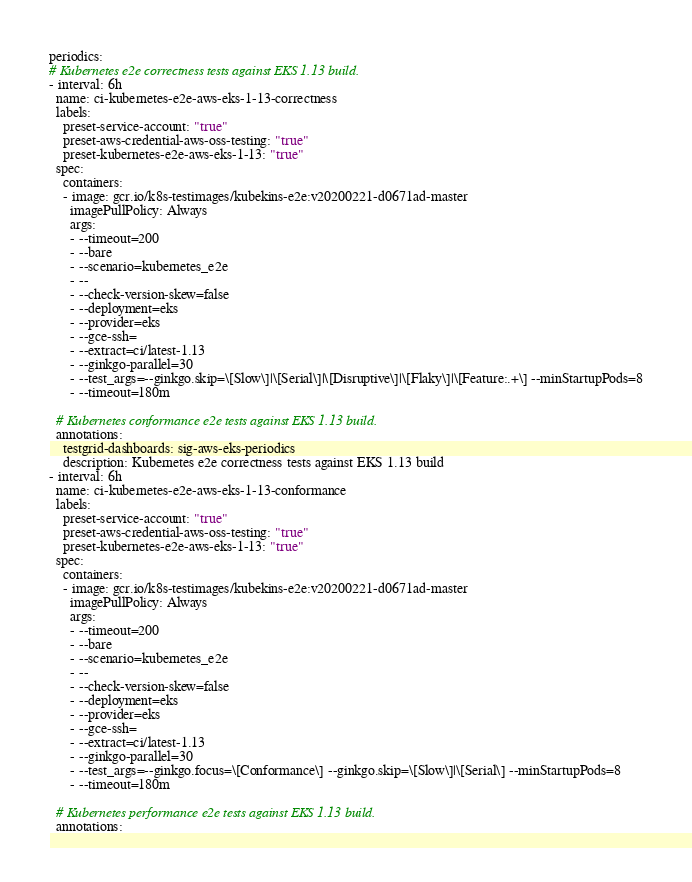<code> <loc_0><loc_0><loc_500><loc_500><_YAML_>periodics:
# Kubernetes e2e correctness tests against EKS 1.13 build.
- interval: 6h
  name: ci-kubernetes-e2e-aws-eks-1-13-correctness
  labels:
    preset-service-account: "true"
    preset-aws-credential-aws-oss-testing: "true"
    preset-kubernetes-e2e-aws-eks-1-13: "true"
  spec:
    containers:
    - image: gcr.io/k8s-testimages/kubekins-e2e:v20200221-d0671ad-master
      imagePullPolicy: Always
      args:
      - --timeout=200
      - --bare
      - --scenario=kubernetes_e2e
      - --
      - --check-version-skew=false
      - --deployment=eks
      - --provider=eks
      - --gce-ssh=
      - --extract=ci/latest-1.13
      - --ginkgo-parallel=30
      - --test_args=--ginkgo.skip=\[Slow\]|\[Serial\]|\[Disruptive\]|\[Flaky\]|\[Feature:.+\] --minStartupPods=8
      - --timeout=180m

  # Kubernetes conformance e2e tests against EKS 1.13 build.
  annotations:
    testgrid-dashboards: sig-aws-eks-periodics
    description: Kubernetes e2e correctness tests against EKS 1.13 build
- interval: 6h
  name: ci-kubernetes-e2e-aws-eks-1-13-conformance
  labels:
    preset-service-account: "true"
    preset-aws-credential-aws-oss-testing: "true"
    preset-kubernetes-e2e-aws-eks-1-13: "true"
  spec:
    containers:
    - image: gcr.io/k8s-testimages/kubekins-e2e:v20200221-d0671ad-master
      imagePullPolicy: Always
      args:
      - --timeout=200
      - --bare
      - --scenario=kubernetes_e2e
      - --
      - --check-version-skew=false
      - --deployment=eks
      - --provider=eks
      - --gce-ssh=
      - --extract=ci/latest-1.13
      - --ginkgo-parallel=30
      - --test_args=--ginkgo.focus=\[Conformance\] --ginkgo.skip=\[Slow\]|\[Serial\] --minStartupPods=8
      - --timeout=180m

  # Kubernetes performance e2e tests against EKS 1.13 build.
  annotations:</code> 